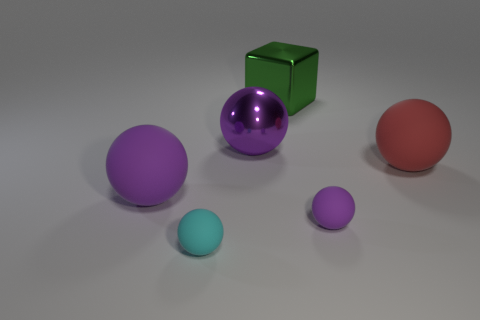Subtract all cyan cubes. How many purple spheres are left? 3 Subtract all small purple spheres. How many spheres are left? 4 Subtract all red balls. How many balls are left? 4 Subtract all cyan balls. Subtract all gray blocks. How many balls are left? 4 Add 3 tiny cyan matte spheres. How many objects exist? 9 Subtract all balls. How many objects are left? 1 Add 3 large rubber balls. How many large rubber balls exist? 5 Subtract 0 green cylinders. How many objects are left? 6 Subtract all large purple blocks. Subtract all big red balls. How many objects are left? 5 Add 6 big red objects. How many big red objects are left? 7 